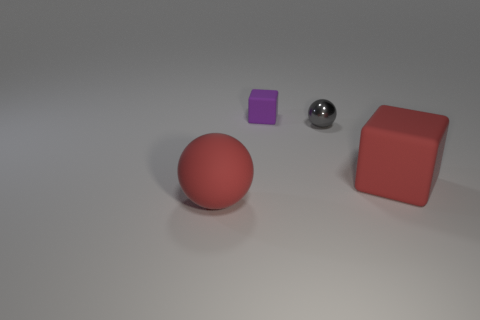Add 1 tiny shiny balls. How many objects exist? 5 Add 4 gray matte spheres. How many gray matte spheres exist? 4 Subtract 1 gray spheres. How many objects are left? 3 Subtract 1 spheres. How many spheres are left? 1 Subtract all gray spheres. Subtract all yellow cylinders. How many spheres are left? 1 Subtract all green cylinders. How many red cubes are left? 1 Subtract all red rubber things. Subtract all red cubes. How many objects are left? 1 Add 2 red things. How many red things are left? 4 